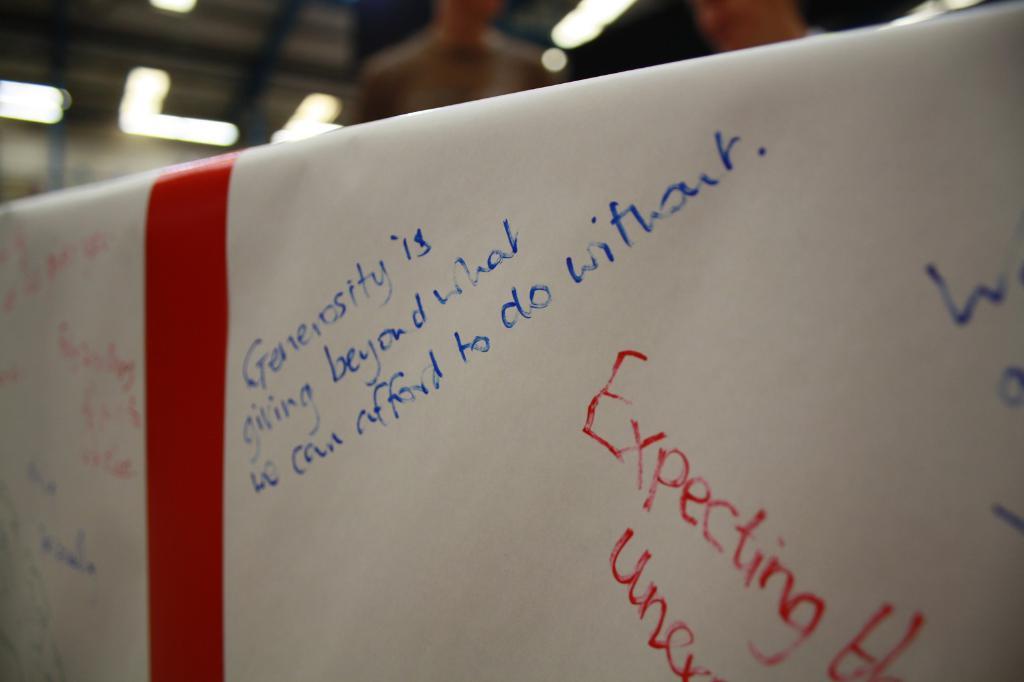What is generosity?
Your answer should be very brief. Giving beyond what we can afford to do without. What is the big red word?
Keep it short and to the point. Expecting. 